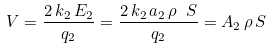<formula> <loc_0><loc_0><loc_500><loc_500>V = \frac { 2 \, k _ { 2 } \, E _ { 2 } } { q _ { 2 } } = \frac { 2 \, k _ { 2 } \, a _ { 2 } \, \rho \ S } { q _ { 2 } } = A _ { 2 } \, \rho \, S</formula> 